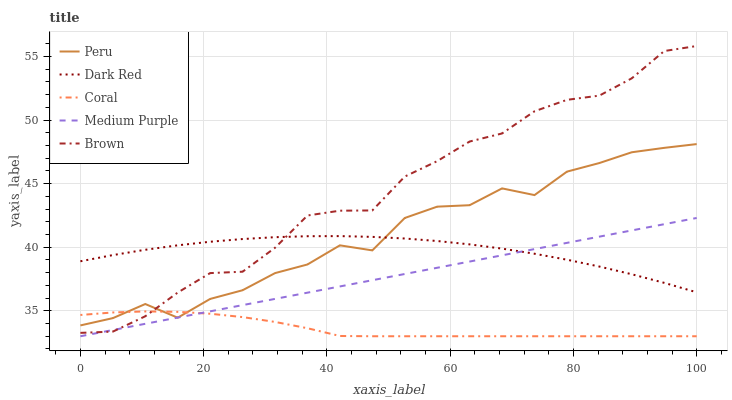Does Coral have the minimum area under the curve?
Answer yes or no. Yes. Does Brown have the maximum area under the curve?
Answer yes or no. Yes. Does Dark Red have the minimum area under the curve?
Answer yes or no. No. Does Dark Red have the maximum area under the curve?
Answer yes or no. No. Is Medium Purple the smoothest?
Answer yes or no. Yes. Is Peru the roughest?
Answer yes or no. Yes. Is Dark Red the smoothest?
Answer yes or no. No. Is Dark Red the roughest?
Answer yes or no. No. Does Dark Red have the lowest value?
Answer yes or no. No. Does Dark Red have the highest value?
Answer yes or no. No. Is Coral less than Dark Red?
Answer yes or no. Yes. Is Dark Red greater than Coral?
Answer yes or no. Yes. Does Coral intersect Dark Red?
Answer yes or no. No. 